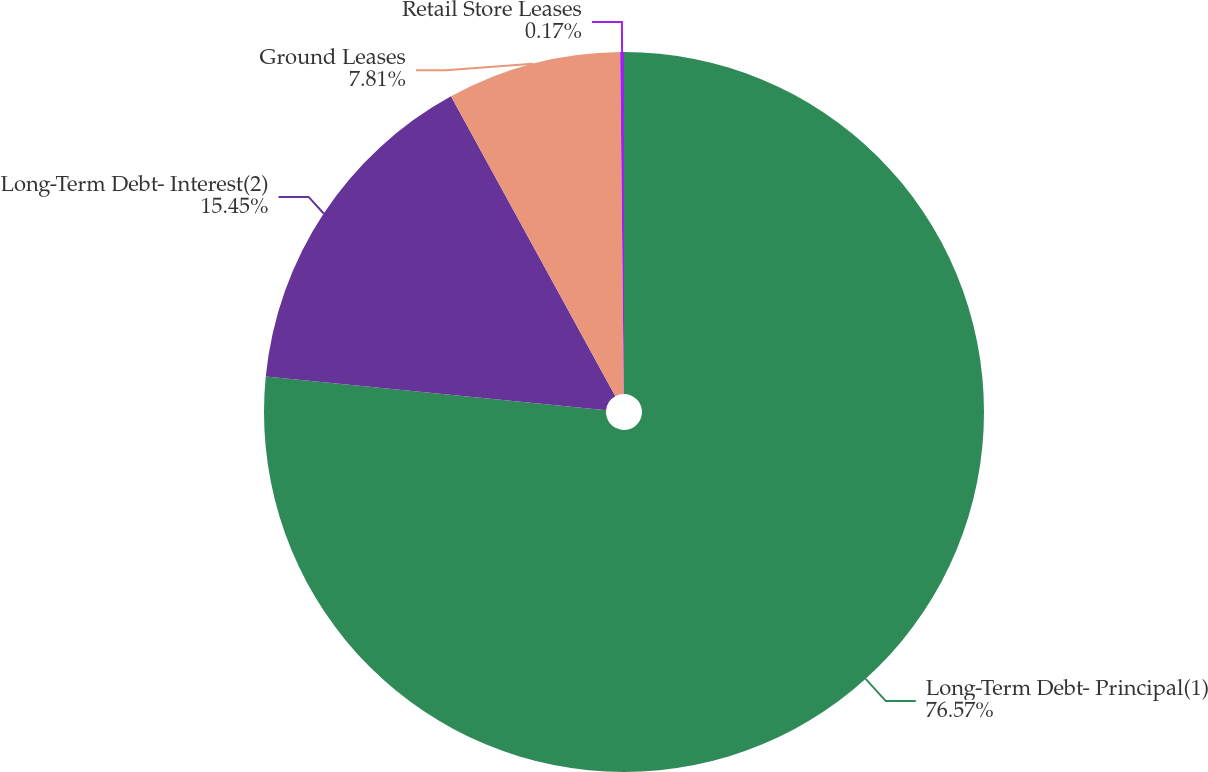<chart> <loc_0><loc_0><loc_500><loc_500><pie_chart><fcel>Long-Term Debt- Principal(1)<fcel>Long-Term Debt- Interest(2)<fcel>Ground Leases<fcel>Retail Store Leases<nl><fcel>76.58%<fcel>15.45%<fcel>7.81%<fcel>0.17%<nl></chart> 